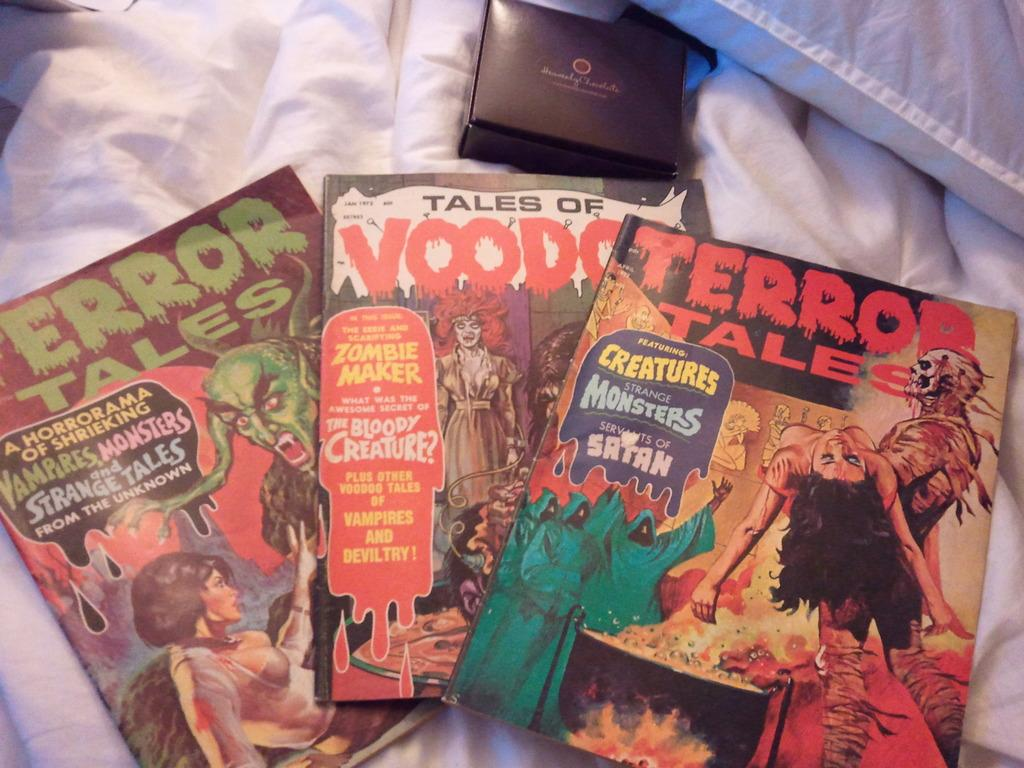<image>
Describe the image concisely. Three comic books called Terror Tales are on a blanket by a brown box. 